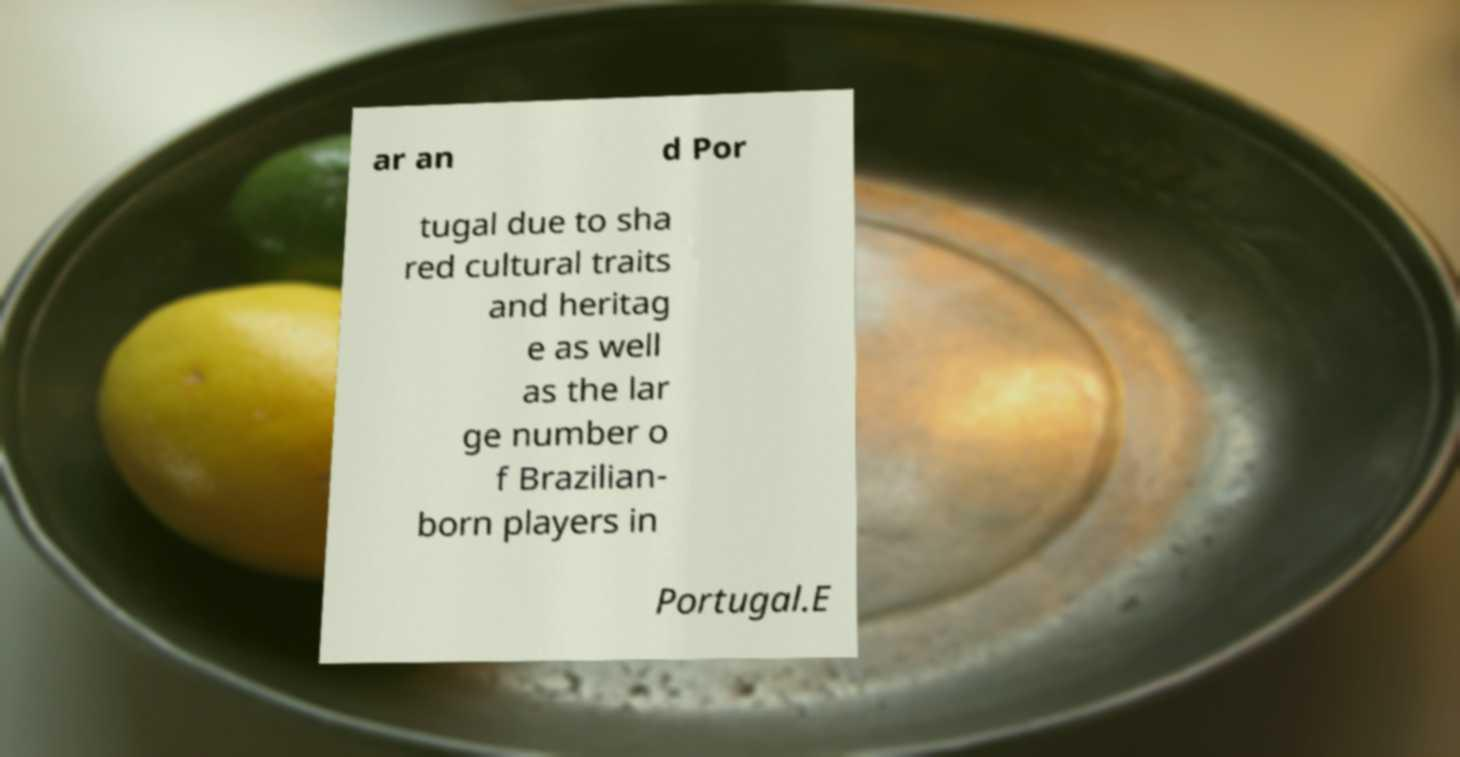Please identify and transcribe the text found in this image. ar an d Por tugal due to sha red cultural traits and heritag e as well as the lar ge number o f Brazilian- born players in Portugal.E 